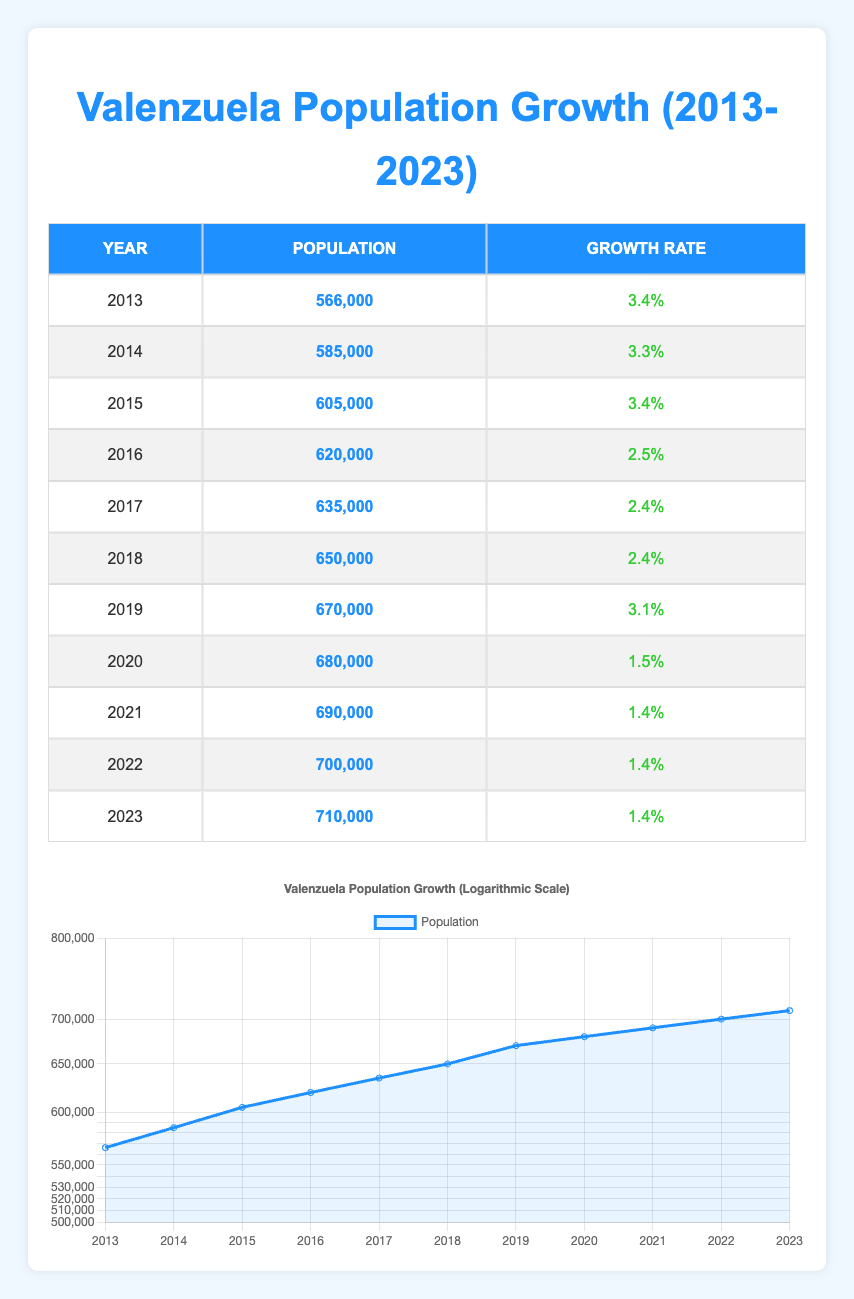What was the population of Valenzuela in 2016? The table shows the population for each year from 2013 to 2023. In 2016, the recorded population is specified as 620,000.
Answer: 620,000 What was the growth rate in 2015? In the table, you can find the growth rate for each year, and for 2015, it is listed as 3.4%.
Answer: 3.4% What is the average population growth rate for the decade from 2013 to 2023? To find the average growth rate, we add the growth rates from each year (0.034 + 0.033 + 0.034 + 0.025 + 0.024 + 0.024 + 0.031 + 0.015 + 0.014 + 0.014 + 0.014) which equals approximately 0.34. Then, divide by the number of years, which is 11. Thus, the average growth rate is 0.34/11 ≈ 0.031 or 3.1%.
Answer: 3.1% Was the population of Valenzuela greater in 2022 than in 2020? From the table, the population in 2022 is listed as 700,000, and in 2020, it is 680,000. Since 700,000 is greater than 680,000, the statement is true.
Answer: Yes What was the total population increase from 2013 to 2023? The population in 2013 was 566,000, and in 2023 it is 710,000. To find the total increase, we subtract the 2013 population from the 2023 population: 710,000 - 566,000 = 144,000.
Answer: 144,000 What year saw a decrease in the growth rate compared to the previous year? By comparing the growth rates year over year, 2016 saw a decrease from 3.4% in 2015 to 2.5% in 2016, indicating that this year had a lower growth rate than the previous one.
Answer: 2016 Was the population growth rate constant from 2014 to 2019? Examining the growth rates, in that period they were 3.3% (2014), 3.4% (2015), 2.5% (2016), 2.4% (2017), 2.4% (2018), and 3.1% (2019). Since the rates vary and are not the same, the statement is false.
Answer: No What was the total population of Valenzuela in even-numbered years? The populations for even-numbered years are: 2014 (585,000), 2016 (620,000), 2018 (650,000), 2020 (680,000), 2022 (700,000). Adding these: 585,000 + 620,000 + 650,000 + 680,000 + 700,000 = 3,235,000.
Answer: 3,235,000 